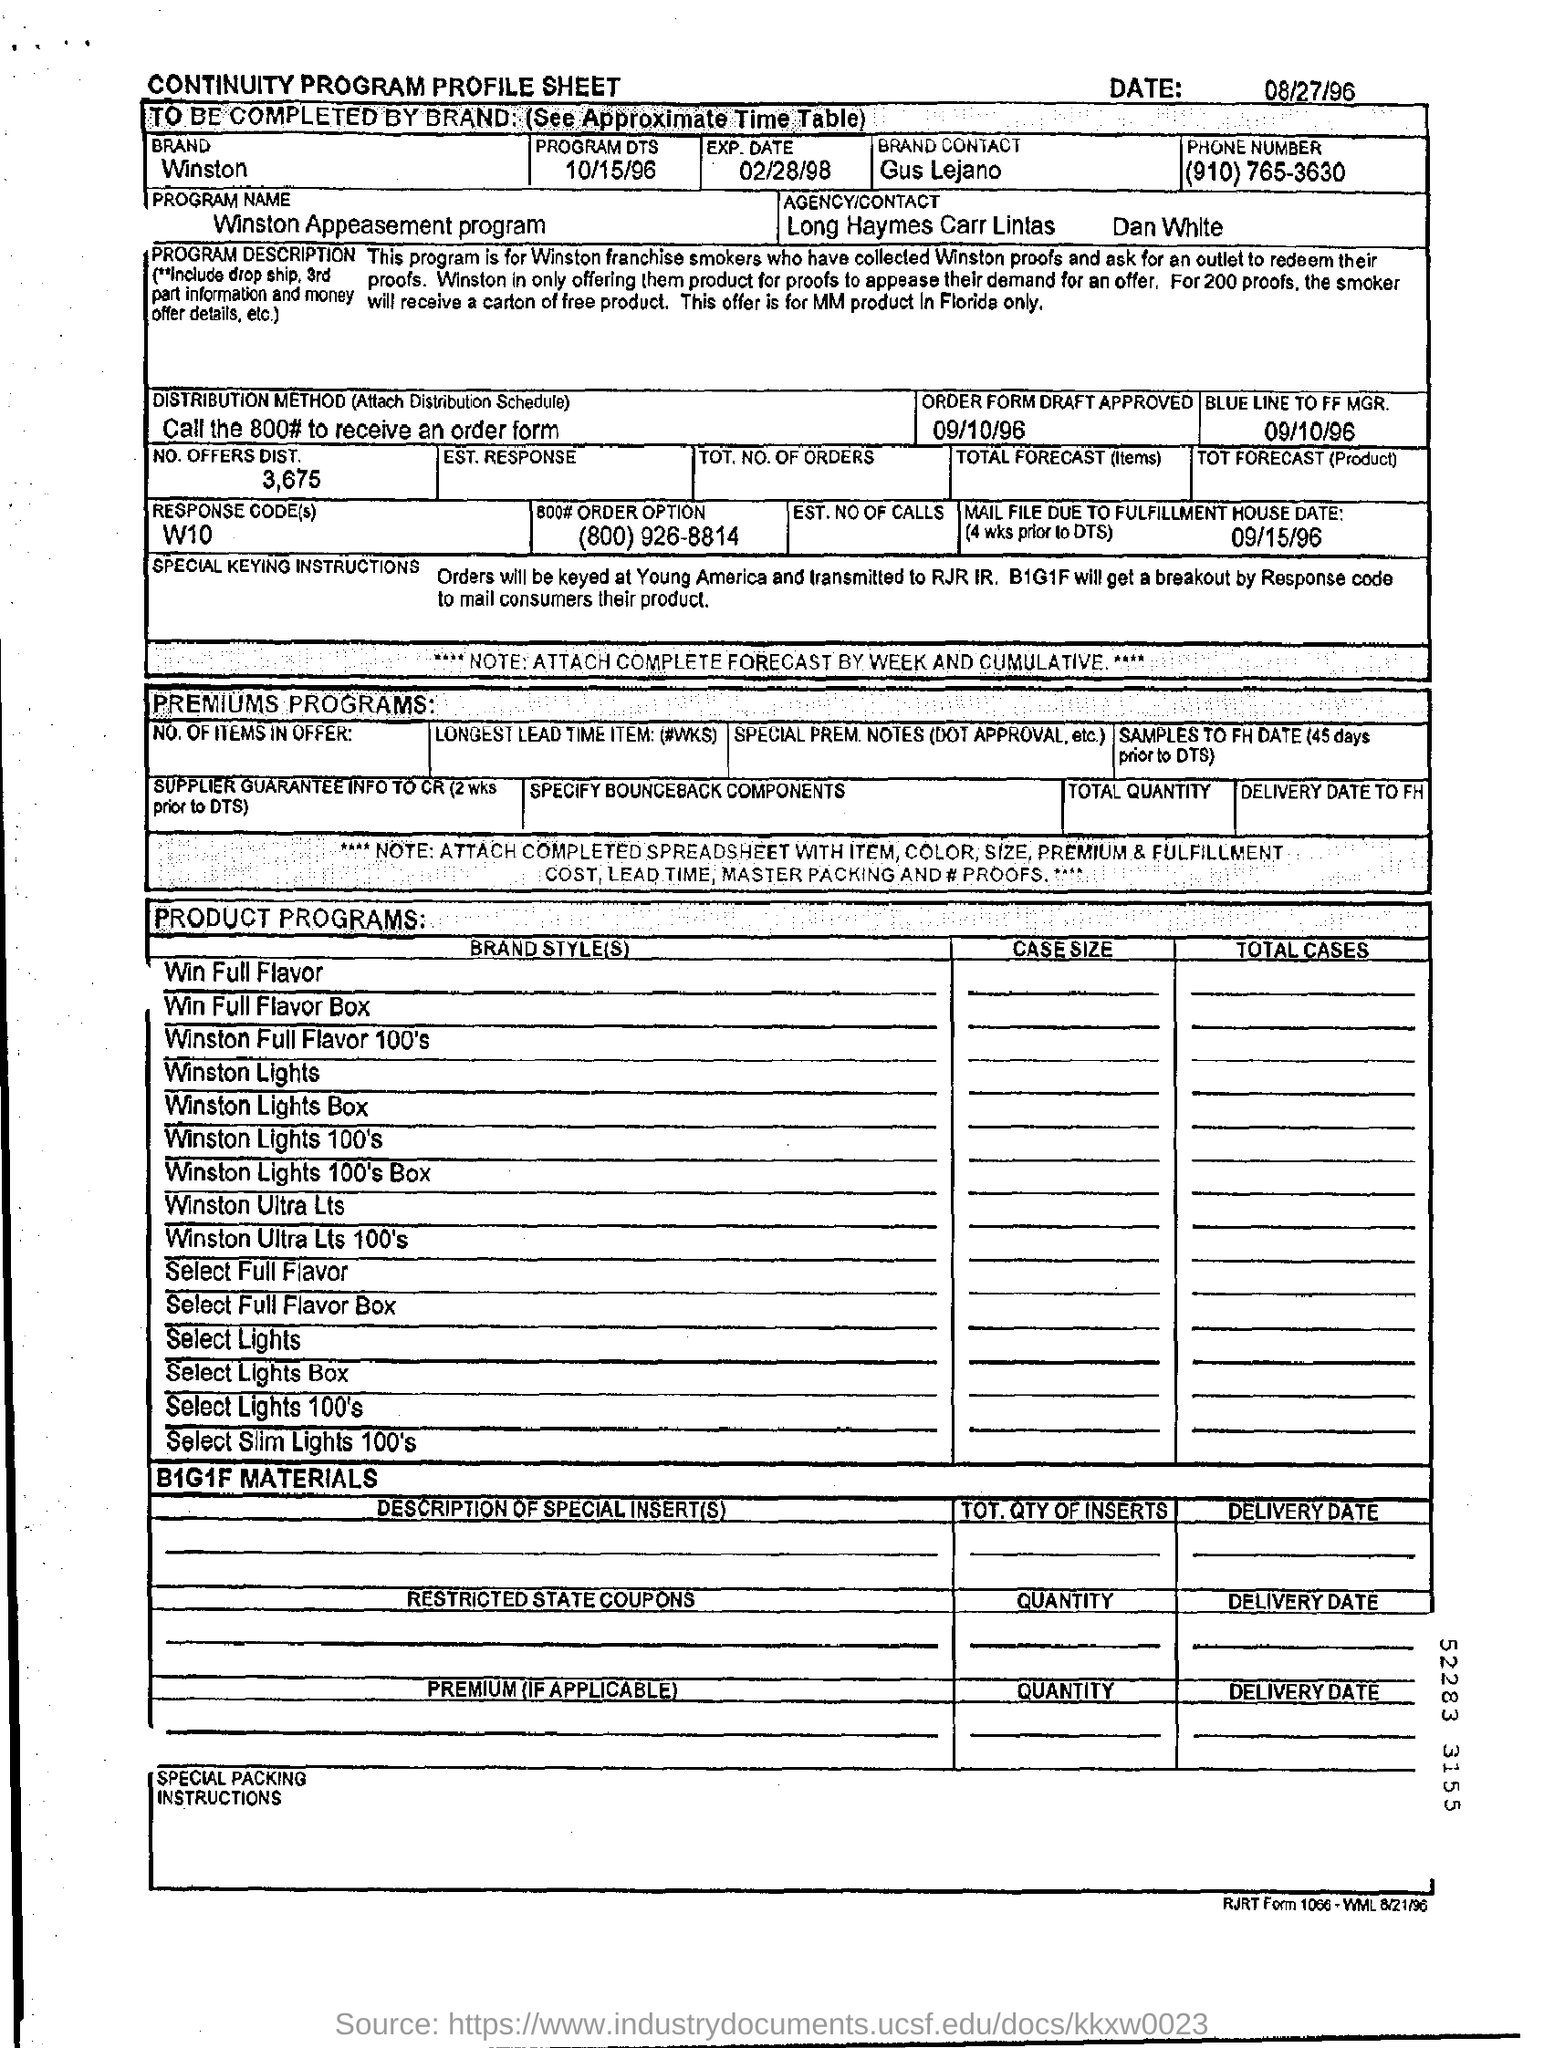Which brand is mentioned in the form?
Provide a succinct answer. Winston. When is the form dated?
Provide a succinct answer. 08/27/96. What is the program name?
Make the answer very short. Winston appeasement program. What is the name of the agency?
Your response must be concise. Long haymes carr lintas. Who is the brand contact?
Your answer should be compact. Gus Lejano. What is the distribution method?
Keep it short and to the point. Call the 800# to receive an order form. What is the Response Code(s)?
Your answer should be compact. W10. 